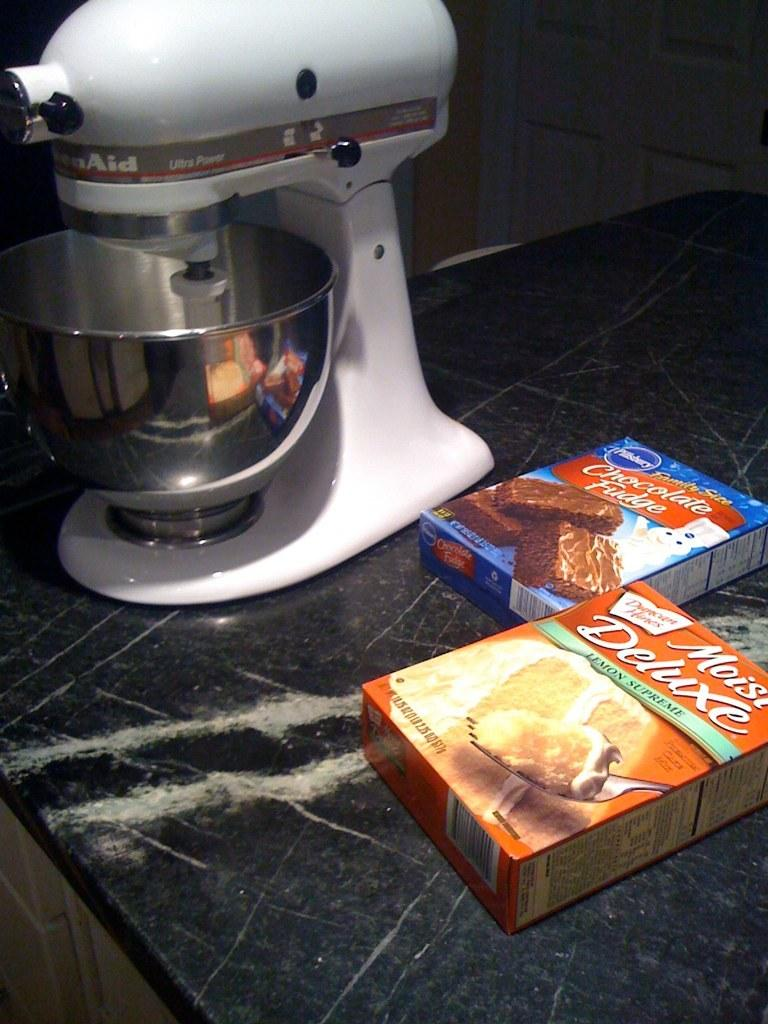<image>
Provide a brief description of the given image. A box of chocolate fudge cake and a box of lemon supreme cake sit next to a mixer on a countertop. 